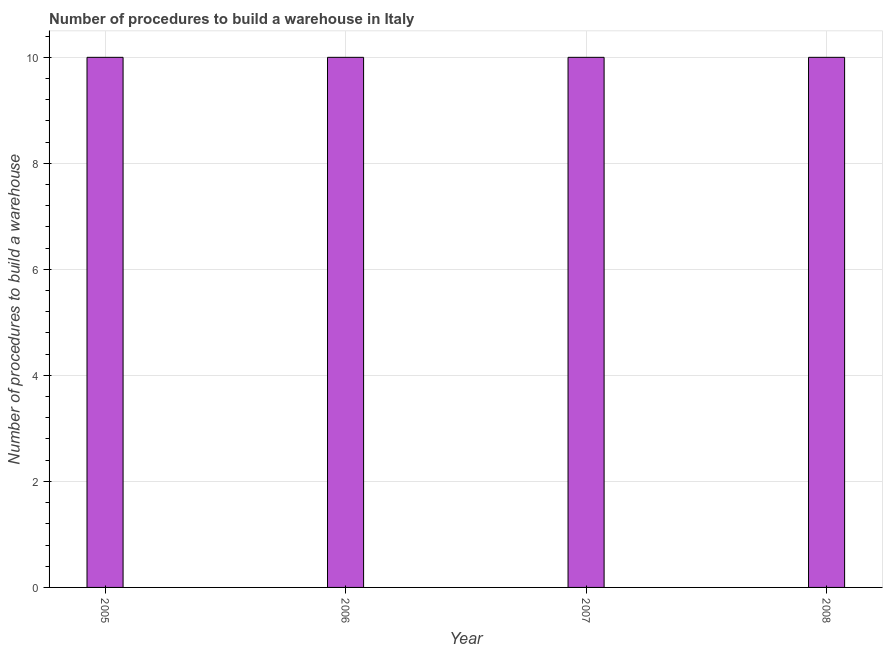What is the title of the graph?
Your answer should be very brief. Number of procedures to build a warehouse in Italy. What is the label or title of the X-axis?
Offer a terse response. Year. What is the label or title of the Y-axis?
Provide a short and direct response. Number of procedures to build a warehouse. What is the number of procedures to build a warehouse in 2006?
Offer a very short reply. 10. What is the average number of procedures to build a warehouse per year?
Ensure brevity in your answer.  10. In how many years, is the number of procedures to build a warehouse greater than 10 ?
Your answer should be compact. 0. Is the number of procedures to build a warehouse in 2005 less than that in 2007?
Ensure brevity in your answer.  No. What is the difference between the highest and the lowest number of procedures to build a warehouse?
Offer a terse response. 0. In how many years, is the number of procedures to build a warehouse greater than the average number of procedures to build a warehouse taken over all years?
Make the answer very short. 0. How many years are there in the graph?
Your response must be concise. 4. What is the Number of procedures to build a warehouse of 2005?
Ensure brevity in your answer.  10. What is the Number of procedures to build a warehouse in 2006?
Keep it short and to the point. 10. What is the Number of procedures to build a warehouse in 2007?
Offer a very short reply. 10. What is the difference between the Number of procedures to build a warehouse in 2005 and 2006?
Your answer should be very brief. 0. What is the difference between the Number of procedures to build a warehouse in 2005 and 2008?
Make the answer very short. 0. What is the ratio of the Number of procedures to build a warehouse in 2005 to that in 2007?
Provide a succinct answer. 1. What is the ratio of the Number of procedures to build a warehouse in 2005 to that in 2008?
Make the answer very short. 1. What is the ratio of the Number of procedures to build a warehouse in 2006 to that in 2007?
Offer a terse response. 1. What is the ratio of the Number of procedures to build a warehouse in 2006 to that in 2008?
Keep it short and to the point. 1. 